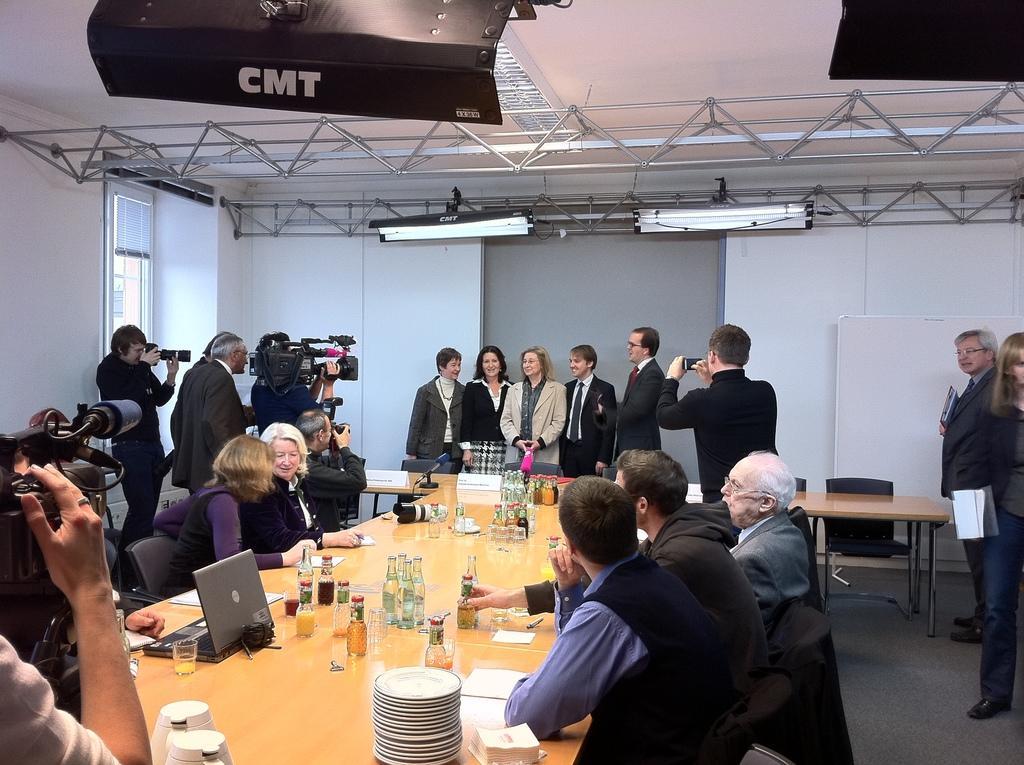In one or two sentences, can you explain what this image depicts? Few persons standing. Few persons sitting on the chair. These four persons holding camera. This is table. On the table we can see bottles,paper,pen,plates,jar. On the background we can see wall. On the top we can see lights. This is floor. This is whiteboard. 